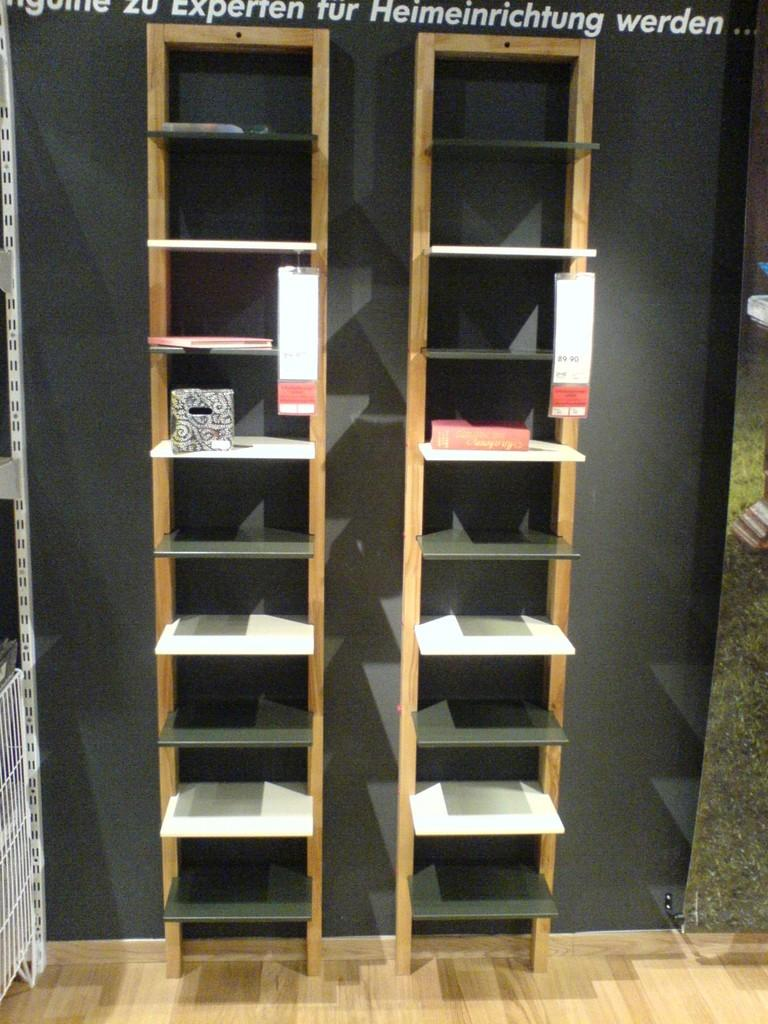What type of storage or display system is visible in the image? There are wooden racks in the image. What is placed on the wooden racks? A cotton box and papers are present on the wooden racks. Can you describe the watermark at the top of the image? There is a watermark at the top of the image, but its specific design or content is not mentioned in the facts. What type of flooring is visible at the bottom of the image? There is a wooden floor at the bottom of the image. How many misty plates are visible on the wooden racks in the image? There are no misty plates present in the image; the facts mention a cotton box and papers on the wooden racks. Are there any balls rolling on the wooden floor in the image? There are no balls visible in the image; the facts mention a wooden floor but do not mention any balls. 